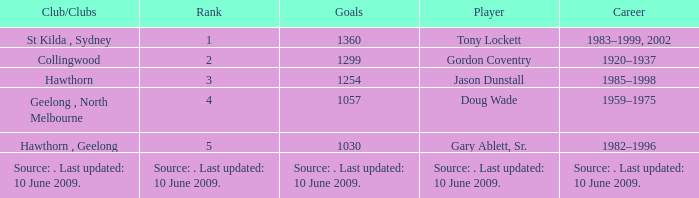In what club(s) does Tony Lockett play? St Kilda , Sydney. 